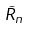Convert formula to latex. <formula><loc_0><loc_0><loc_500><loc_500>\tilde { R } _ { n }</formula> 